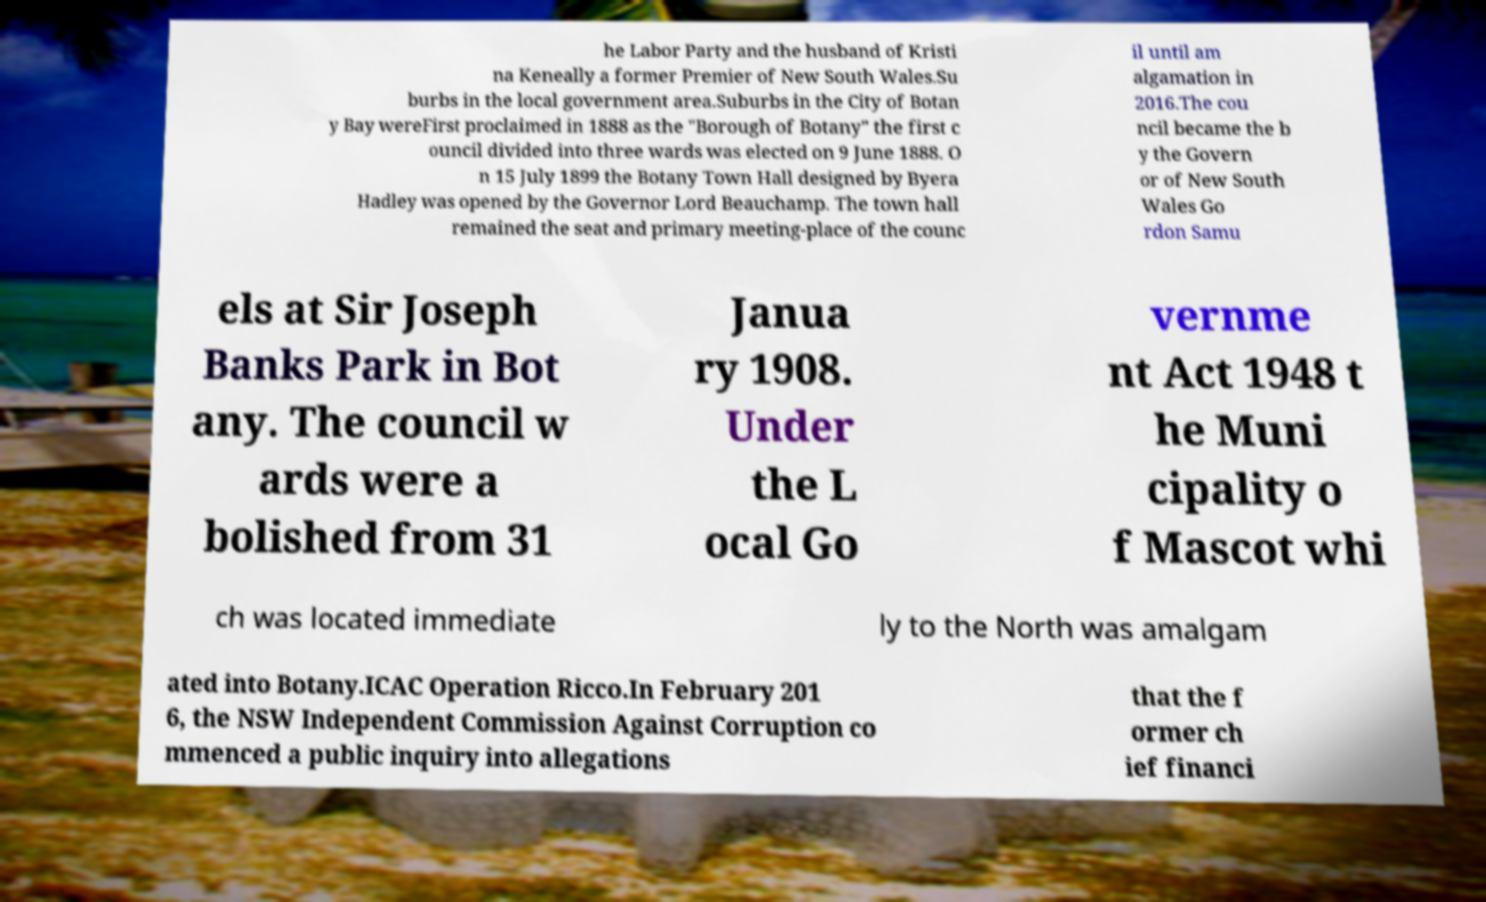Can you read and provide the text displayed in the image?This photo seems to have some interesting text. Can you extract and type it out for me? he Labor Party and the husband of Kristi na Keneally a former Premier of New South Wales.Su burbs in the local government area.Suburbs in the City of Botan y Bay wereFirst proclaimed in 1888 as the "Borough of Botany" the first c ouncil divided into three wards was elected on 9 June 1888. O n 15 July 1899 the Botany Town Hall designed by Byera Hadley was opened by the Governor Lord Beauchamp. The town hall remained the seat and primary meeting-place of the counc il until am algamation in 2016.The cou ncil became the b y the Govern or of New South Wales Go rdon Samu els at Sir Joseph Banks Park in Bot any. The council w ards were a bolished from 31 Janua ry 1908. Under the L ocal Go vernme nt Act 1948 t he Muni cipality o f Mascot whi ch was located immediate ly to the North was amalgam ated into Botany.ICAC Operation Ricco.In February 201 6, the NSW Independent Commission Against Corruption co mmenced a public inquiry into allegations that the f ormer ch ief financi 